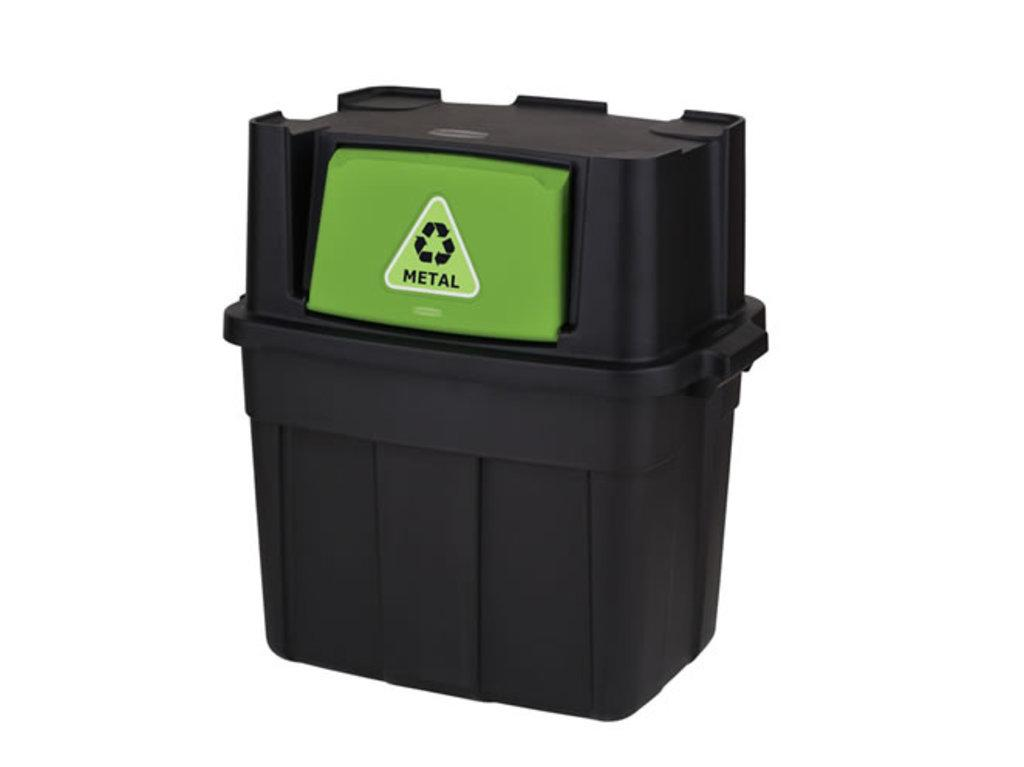<image>
Provide a brief description of the given image. a black and green plastic container for recycling METAL. 